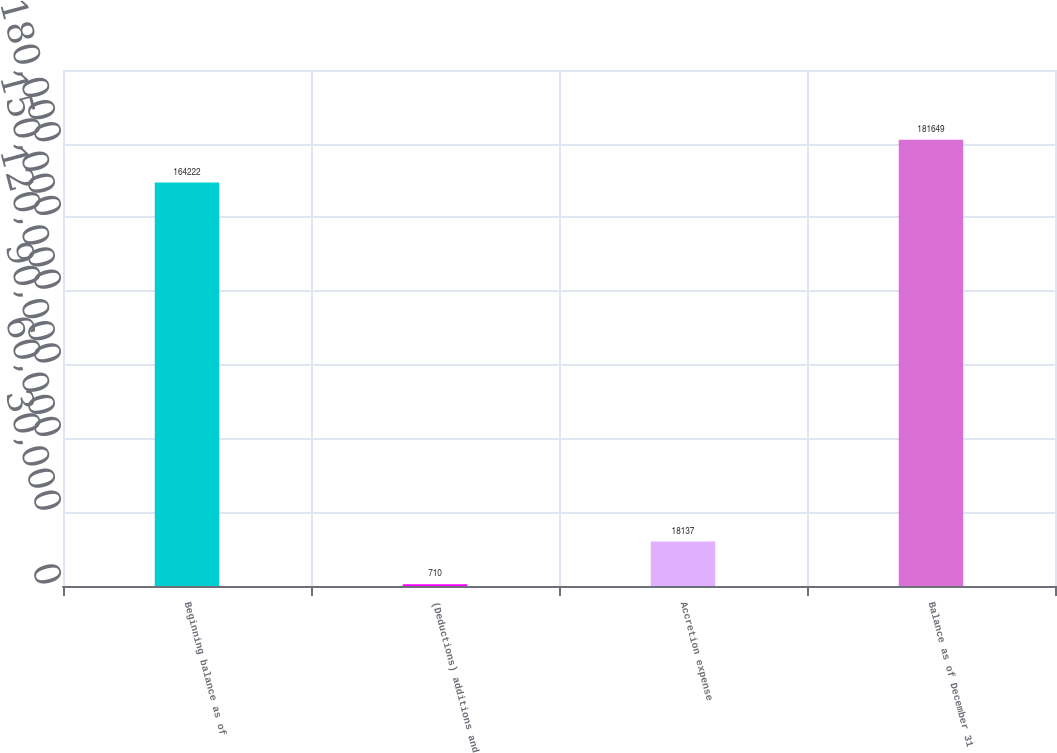Convert chart to OTSL. <chart><loc_0><loc_0><loc_500><loc_500><bar_chart><fcel>Beginning balance as of<fcel>(Deductions) additions and<fcel>Accretion expense<fcel>Balance as of December 31<nl><fcel>164222<fcel>710<fcel>18137<fcel>181649<nl></chart> 